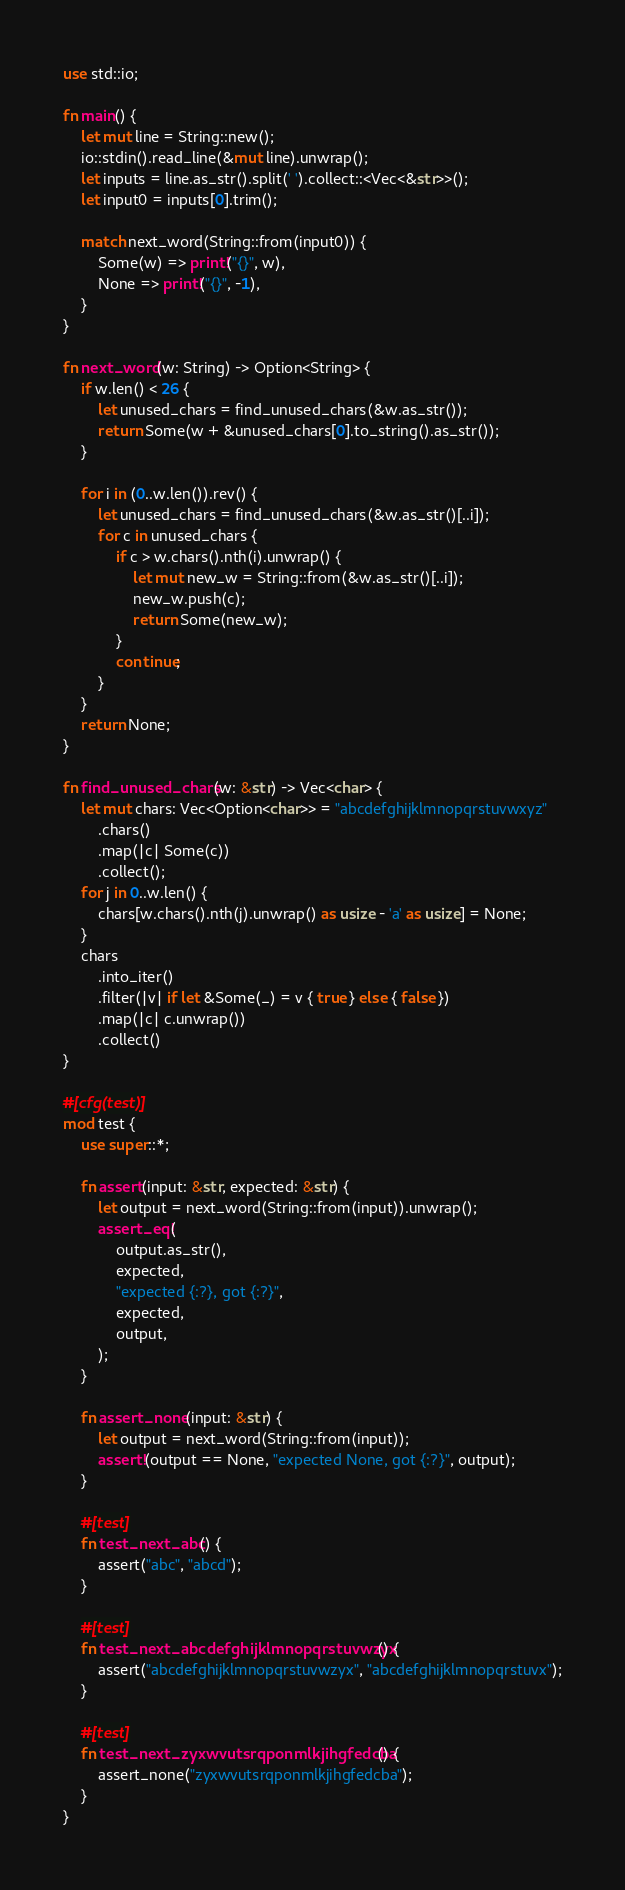<code> <loc_0><loc_0><loc_500><loc_500><_Rust_>use std::io;

fn main() {
    let mut line = String::new();
    io::stdin().read_line(&mut line).unwrap();
    let inputs = line.as_str().split(' ').collect::<Vec<&str>>();
    let input0 = inputs[0].trim();

    match next_word(String::from(input0)) {
        Some(w) => print!("{}", w),
        None => print!("{}", -1),
    }
}

fn next_word(w: String) -> Option<String> {
    if w.len() < 26 {
        let unused_chars = find_unused_chars(&w.as_str());
        return Some(w + &unused_chars[0].to_string().as_str());
    }

    for i in (0..w.len()).rev() {
        let unused_chars = find_unused_chars(&w.as_str()[..i]);
        for c in unused_chars {
            if c > w.chars().nth(i).unwrap() {
                let mut new_w = String::from(&w.as_str()[..i]);
                new_w.push(c);
                return Some(new_w);
            }
            continue;
        }
    }
    return None;
}

fn find_unused_chars(w: &str) -> Vec<char> {
    let mut chars: Vec<Option<char>> = "abcdefghijklmnopqrstuvwxyz"
        .chars()
        .map(|c| Some(c))
        .collect();
    for j in 0..w.len() {
        chars[w.chars().nth(j).unwrap() as usize - 'a' as usize] = None;
    }
    chars
        .into_iter()
        .filter(|v| if let &Some(_) = v { true } else { false })
        .map(|c| c.unwrap())
        .collect()
}

#[cfg(test)]
mod test {
    use super::*;

    fn assert(input: &str, expected: &str) {
        let output = next_word(String::from(input)).unwrap();
        assert_eq!(
            output.as_str(),
            expected,
            "expected {:?}, got {:?}",
            expected,
            output,
        );
    }

    fn assert_none(input: &str) {
        let output = next_word(String::from(input));
        assert!(output == None, "expected None, got {:?}", output);
    }

    #[test]
    fn test_next_abc() {
        assert("abc", "abcd");
    }

    #[test]
    fn test_next_abcdefghijklmnopqrstuvwzyx() {
        assert("abcdefghijklmnopqrstuvwzyx", "abcdefghijklmnopqrstuvx");
    }

    #[test]
    fn test_next_zyxwvutsrqponmlkjihgfedcba() {
        assert_none("zyxwvutsrqponmlkjihgfedcba");
    }
}
</code> 